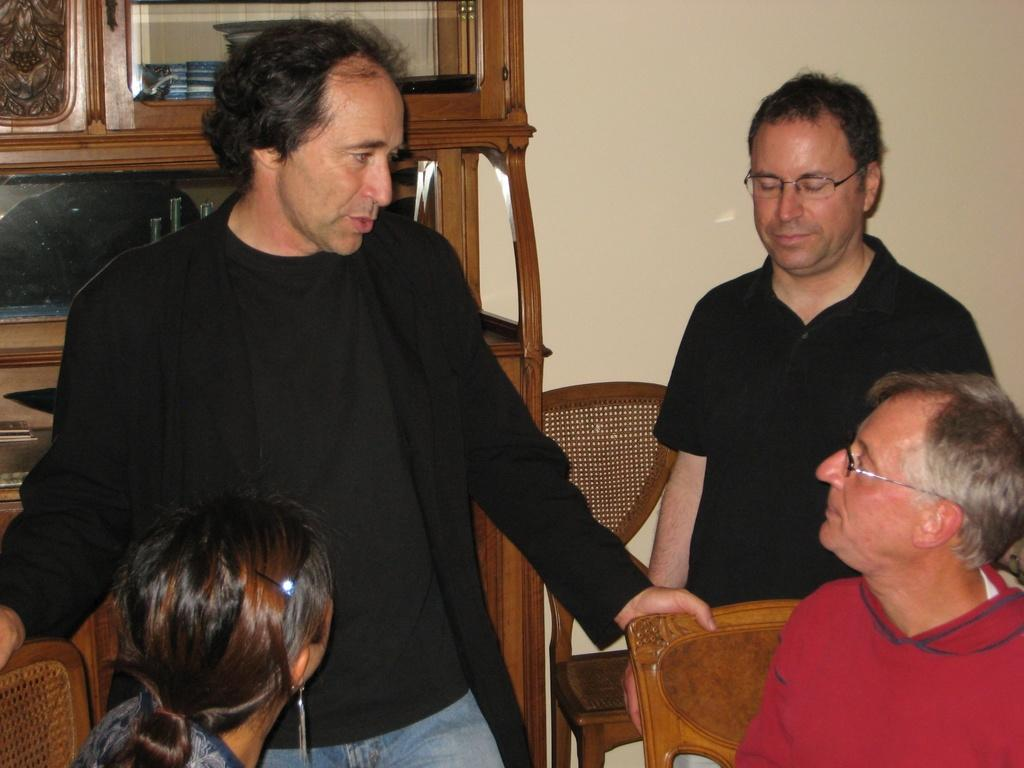How many people are in the image? There is a group of persons in the image. What are the people in the image doing? Some of the persons are sitting, while others are standing. What can be seen in the background of the image? There is a wall and a cupboard in the background of the image. What type of drug can be seen in the hands of the person in the image? There is no drug present in the image; it features a group of persons with some sitting and others standing, along with a wall and a cupboard in the background. 